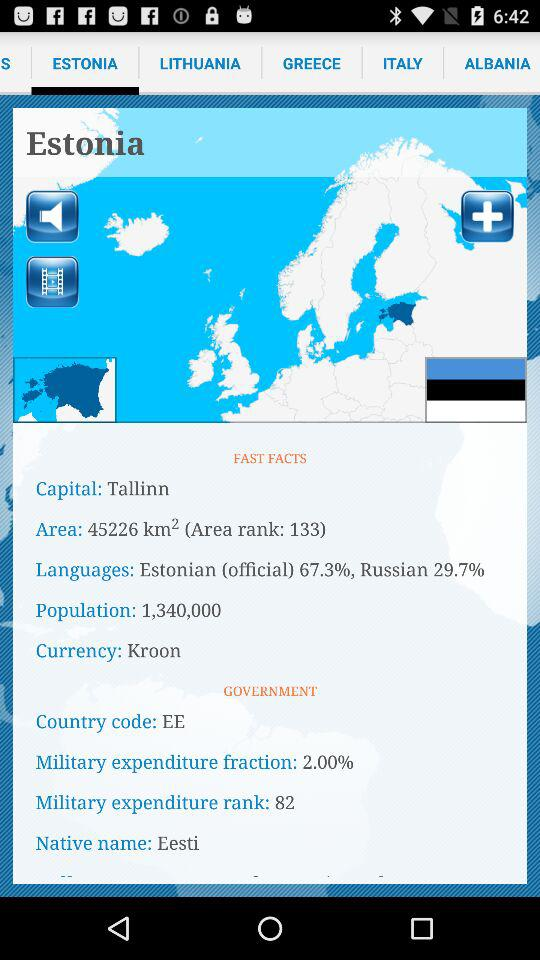How much is the population? The population is 1,340,000. 